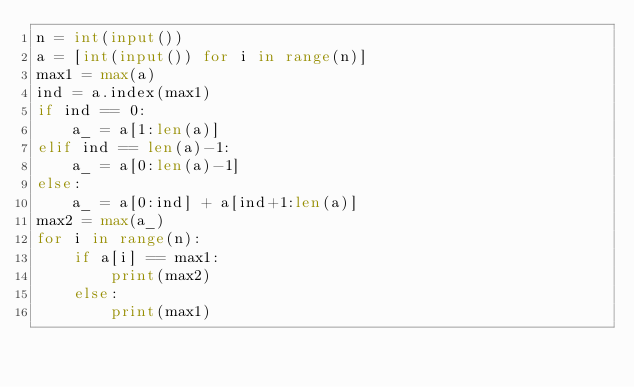<code> <loc_0><loc_0><loc_500><loc_500><_Python_>n = int(input())
a = [int(input()) for i in range(n)]
max1 = max(a)
ind = a.index(max1)
if ind == 0:
    a_ = a[1:len(a)]
elif ind == len(a)-1:
    a_ = a[0:len(a)-1]
else:
    a_ = a[0:ind] + a[ind+1:len(a)]
max2 = max(a_)
for i in range(n):
    if a[i] == max1:
        print(max2)
    else:
        print(max1)</code> 